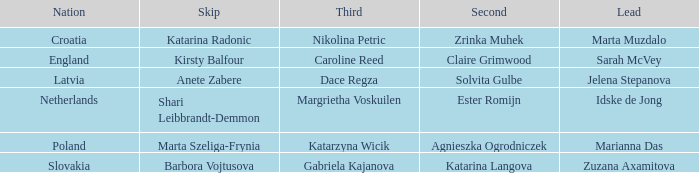Which skip features zrinka muhek as the second? Katarina Radonic. 